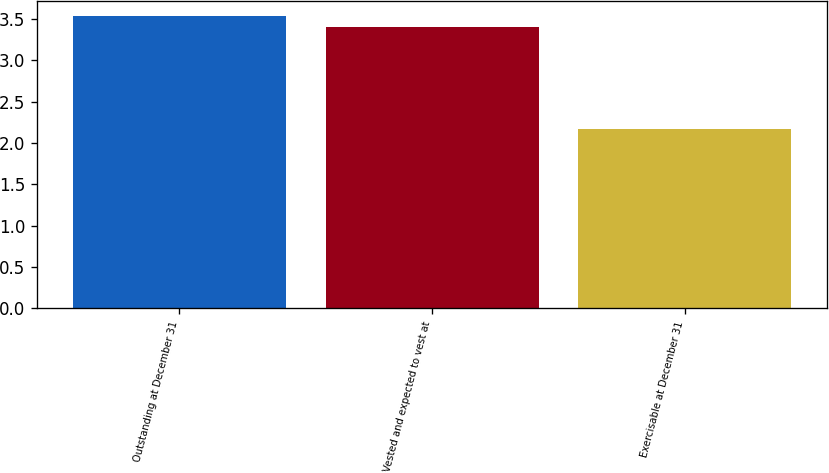Convert chart. <chart><loc_0><loc_0><loc_500><loc_500><bar_chart><fcel>Outstanding at December 31<fcel>Vested and expected to vest at<fcel>Exercisable at December 31<nl><fcel>3.54<fcel>3.41<fcel>2.17<nl></chart> 